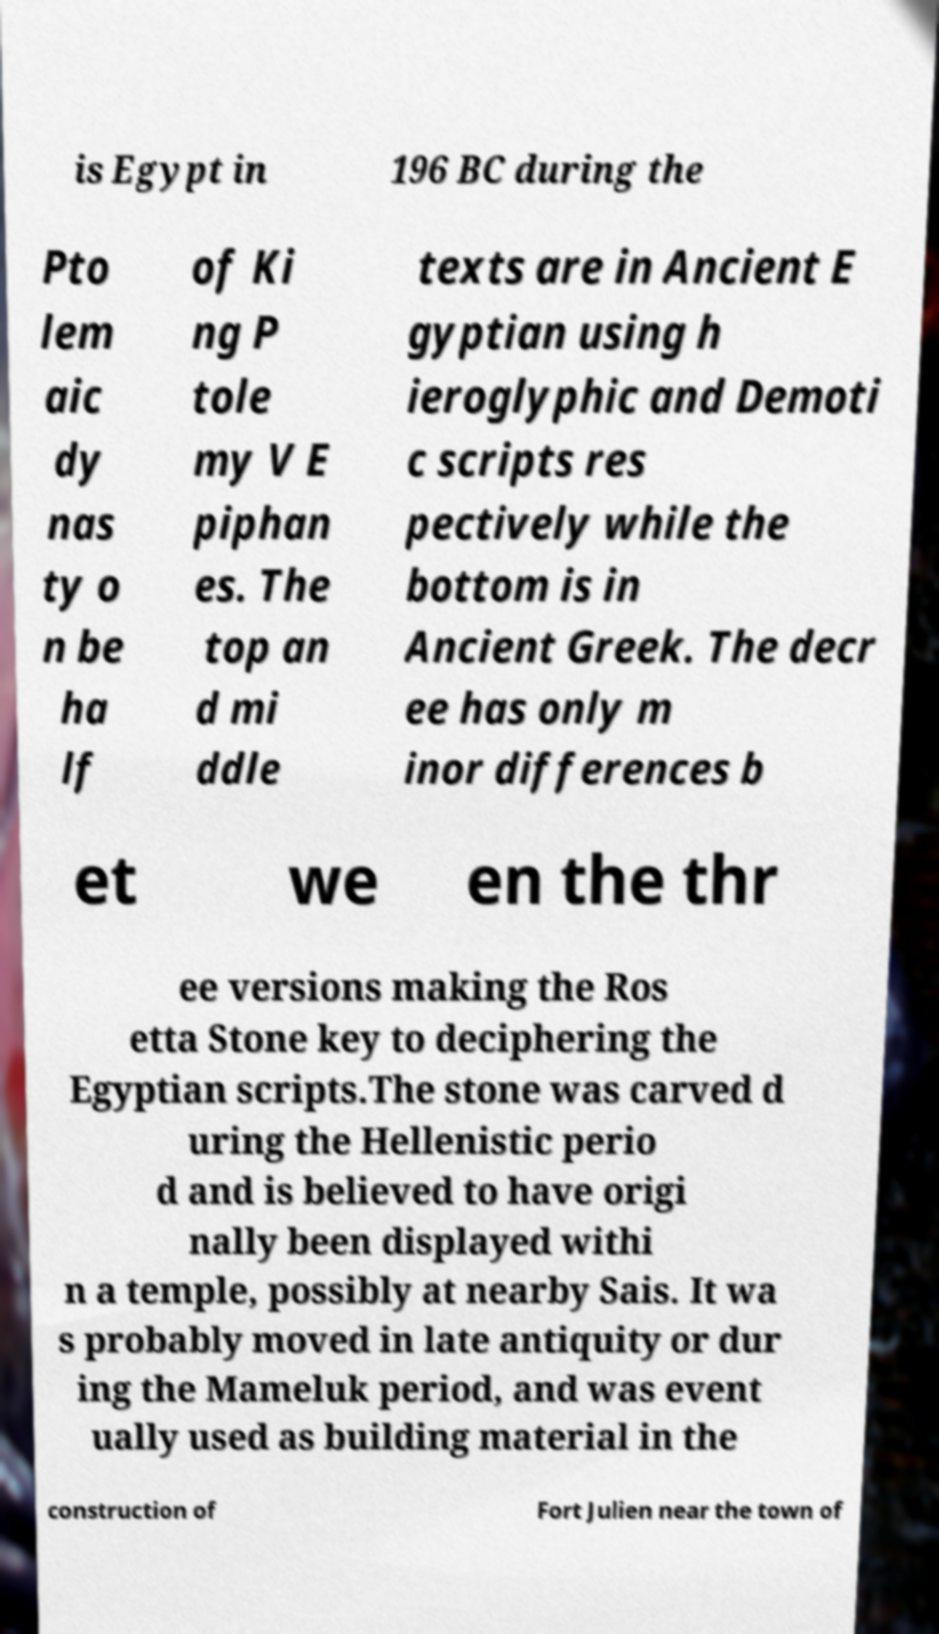Could you extract and type out the text from this image? is Egypt in 196 BC during the Pto lem aic dy nas ty o n be ha lf of Ki ng P tole my V E piphan es. The top an d mi ddle texts are in Ancient E gyptian using h ieroglyphic and Demoti c scripts res pectively while the bottom is in Ancient Greek. The decr ee has only m inor differences b et we en the thr ee versions making the Ros etta Stone key to deciphering the Egyptian scripts.The stone was carved d uring the Hellenistic perio d and is believed to have origi nally been displayed withi n a temple, possibly at nearby Sais. It wa s probably moved in late antiquity or dur ing the Mameluk period, and was event ually used as building material in the construction of Fort Julien near the town of 